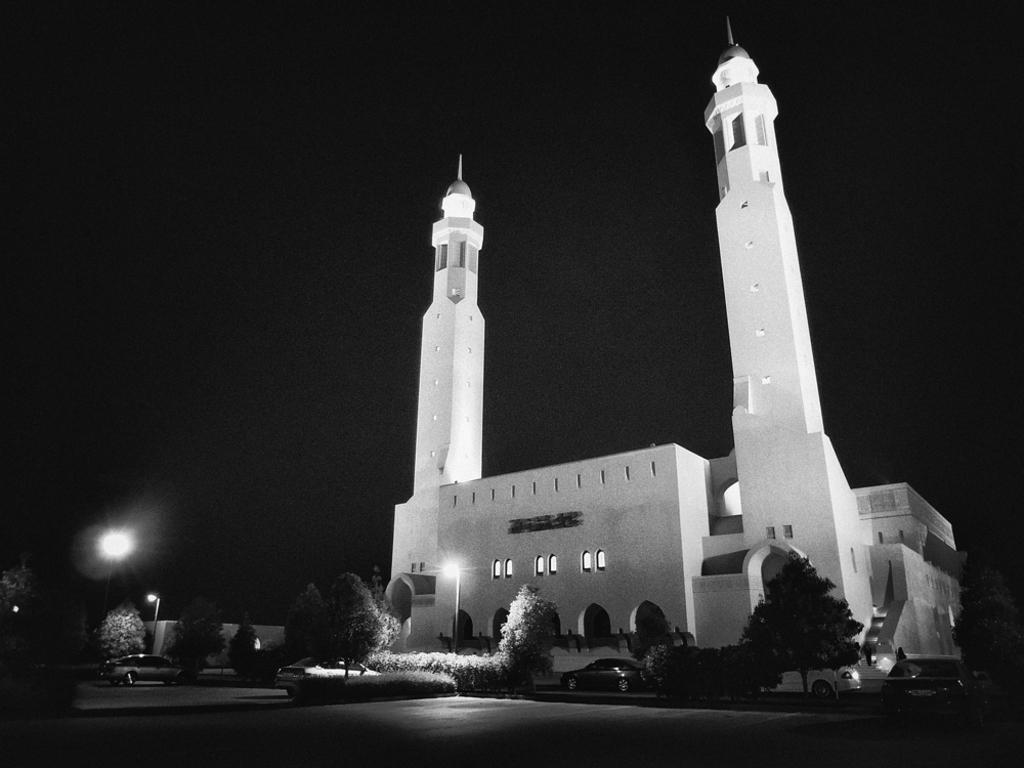What is the main structure in the center of the image? There is a mosque in the center of the image. What type of vegetation can be seen in the image? There are trees in the image. What type of lighting is present in the image? There are street lights in the image. Can you see a toad sitting on the roof of the mosque in the image? There is no toad present on the roof of the mosque in the image. What wish can be granted by the mosque in the image? The image does not depict any wishes being granted; it is a visual representation of a mosque and its surroundings. 